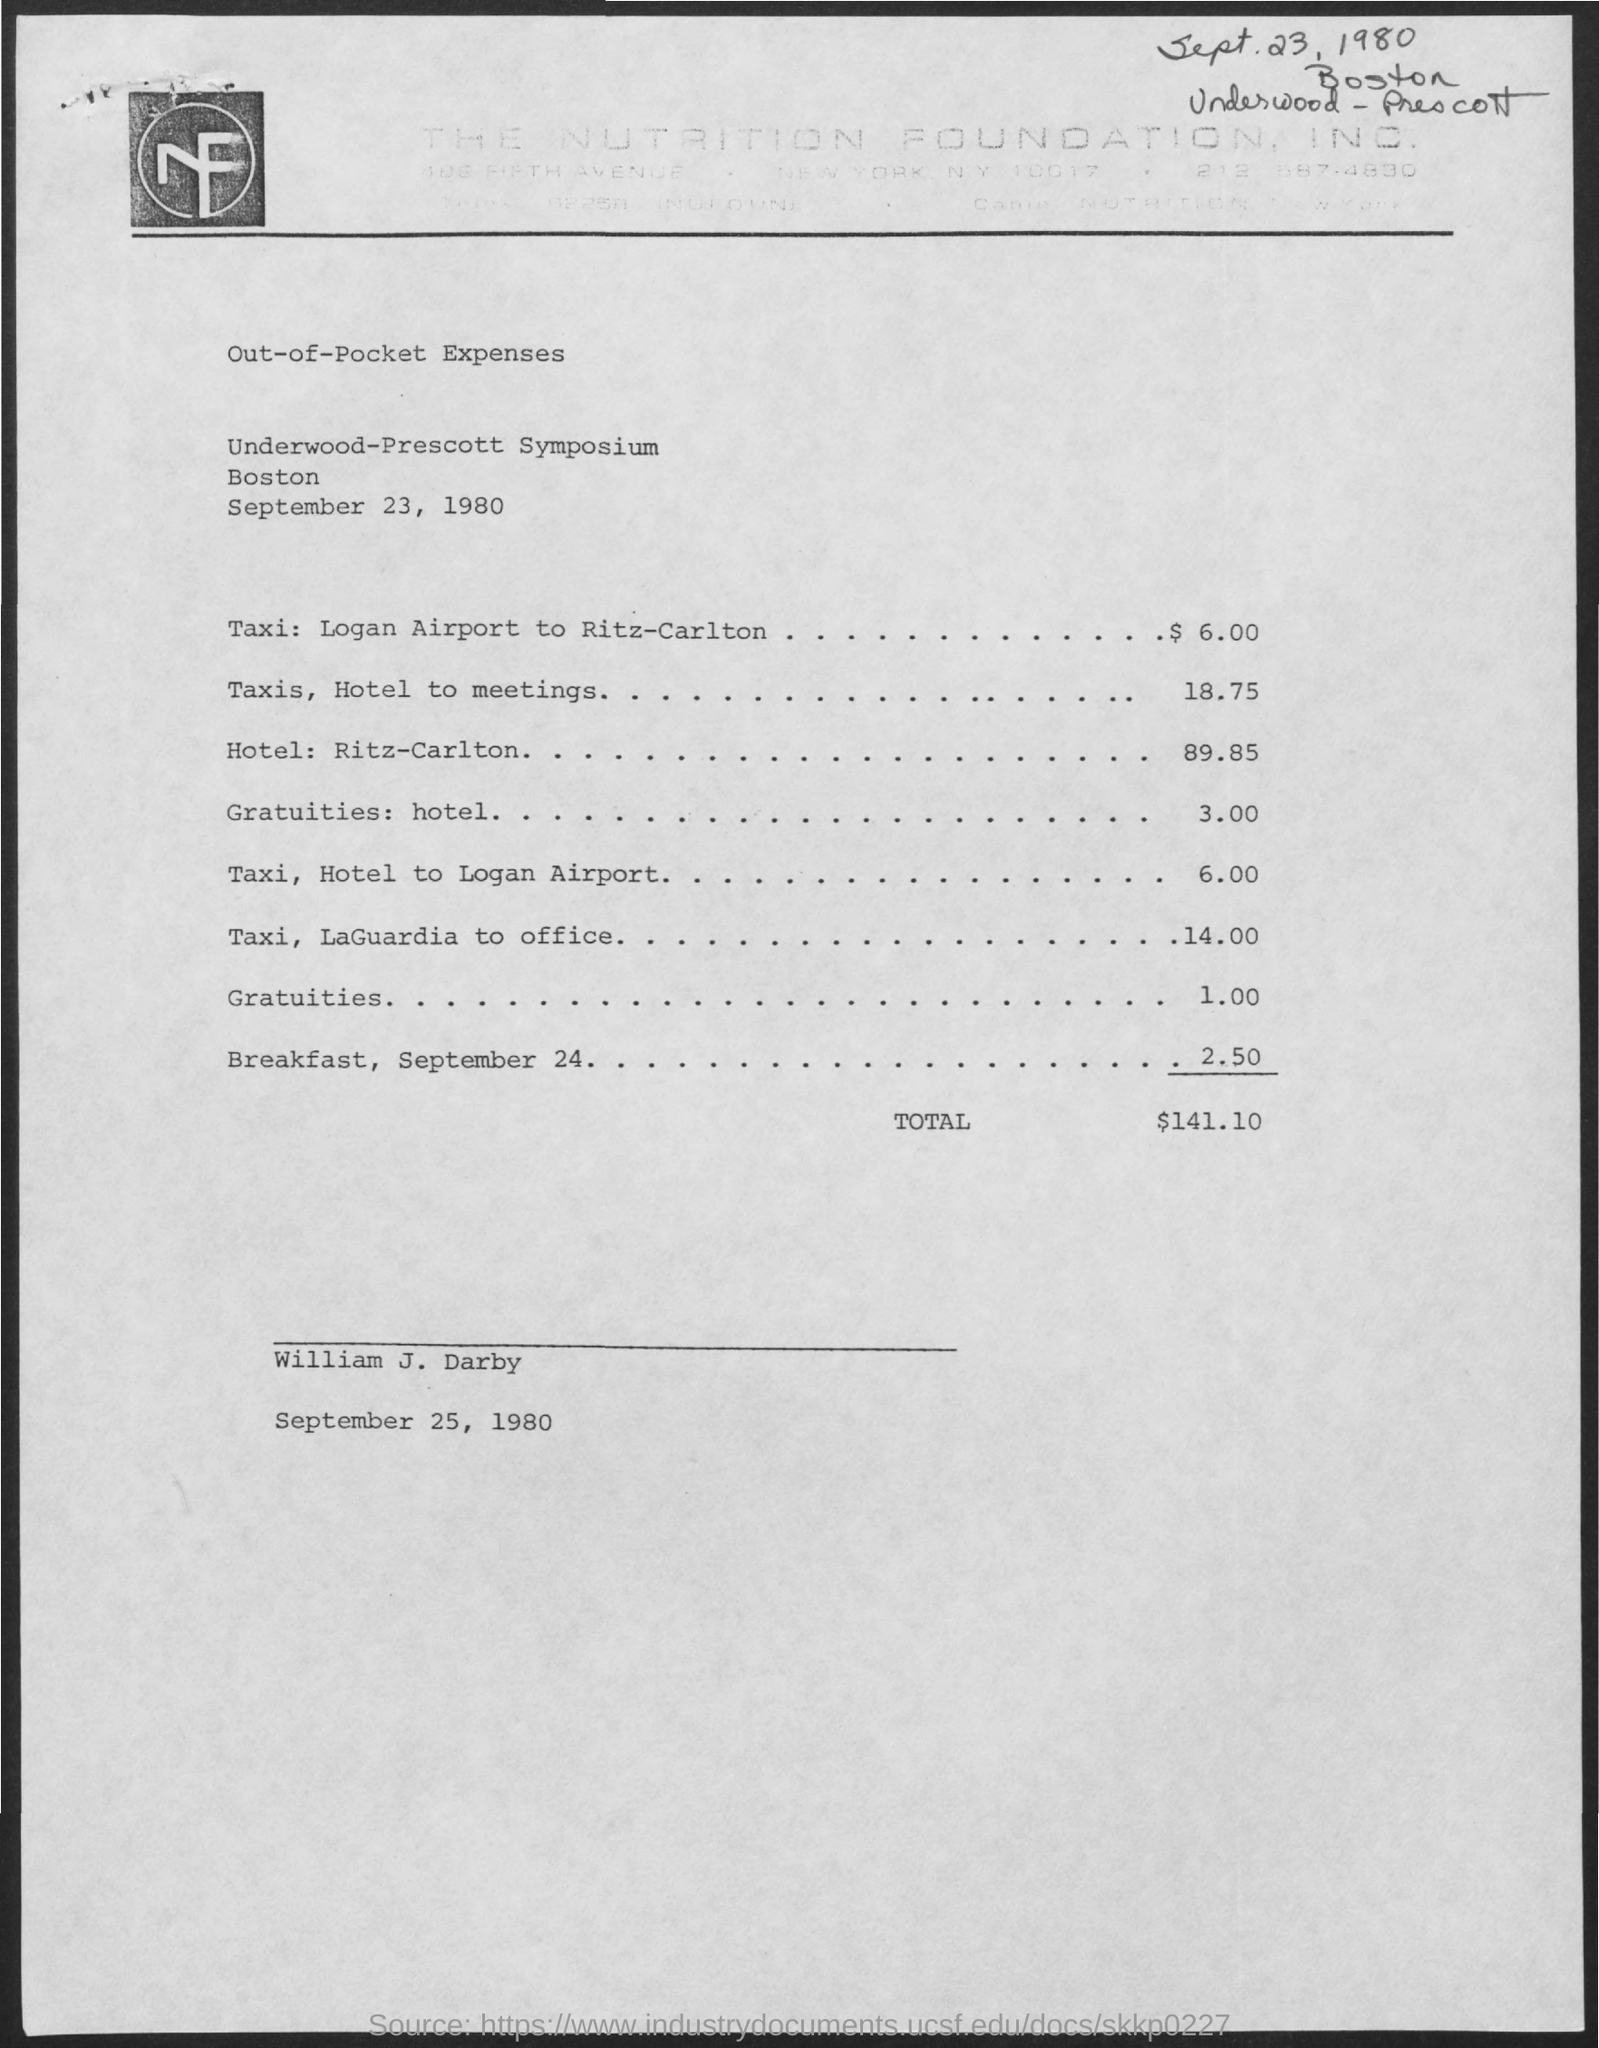Specify some key components in this picture. The hotel includes $3.00 in gratuities for expenses. The total expenses amount to $141.10. 